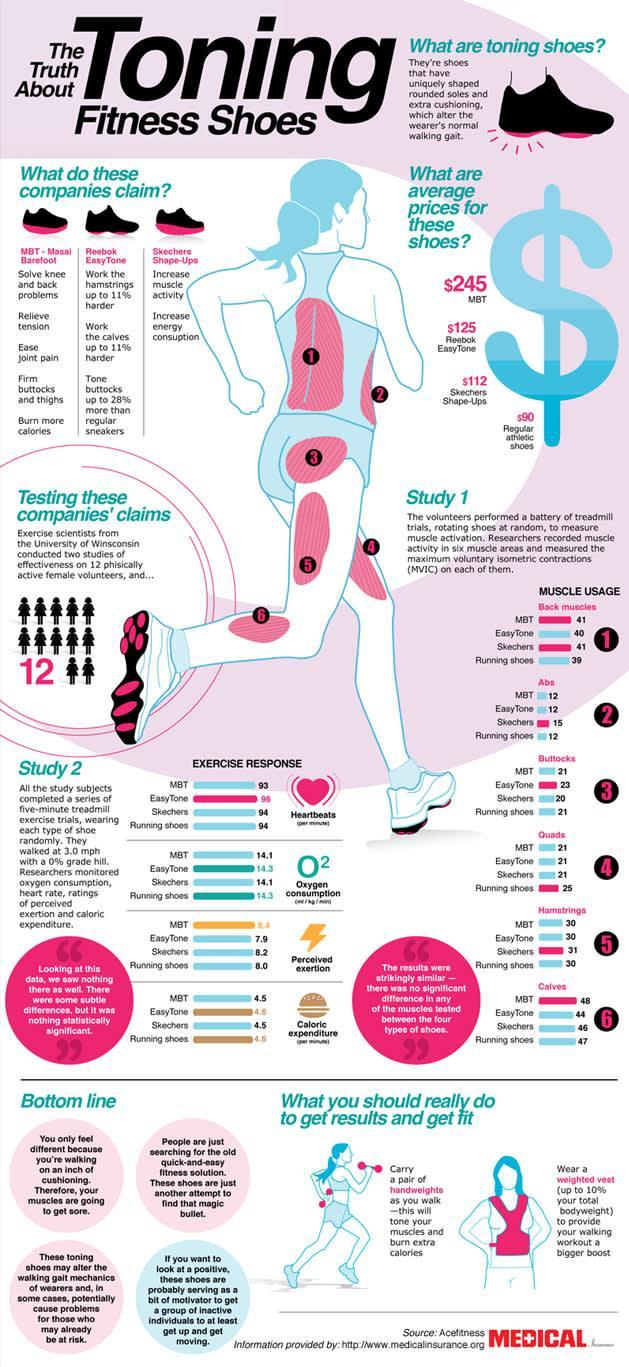Which brand claims that their toning shoes will solve knee and back problems?
Answer the question with a short phrase. MBT - Masai Barefoot Which brand claims their toning shoes will ease joint pain and relieve tension? MBT - Masai Barefoot In the image of the running female, which muscles are marked by the number 1? Back muscles Which brand claims their shoes will increase muscle activity? Skechers Shape-Ups Which brand claims that their toning shoes work the hamstrings and the calves up to 11% harder? Reebok EasyTone In the image of the running female, which muscles are marked by the number 6? Calves What is the average price of Reebok Easy Tone shoes? $125 Which brand's toning shoes costs $245? MBT What is the average cost of a regular pair of athletic shoes? $90 Which brand's toning shoes come at an average cost of $112? Skechers Shape-Ups 